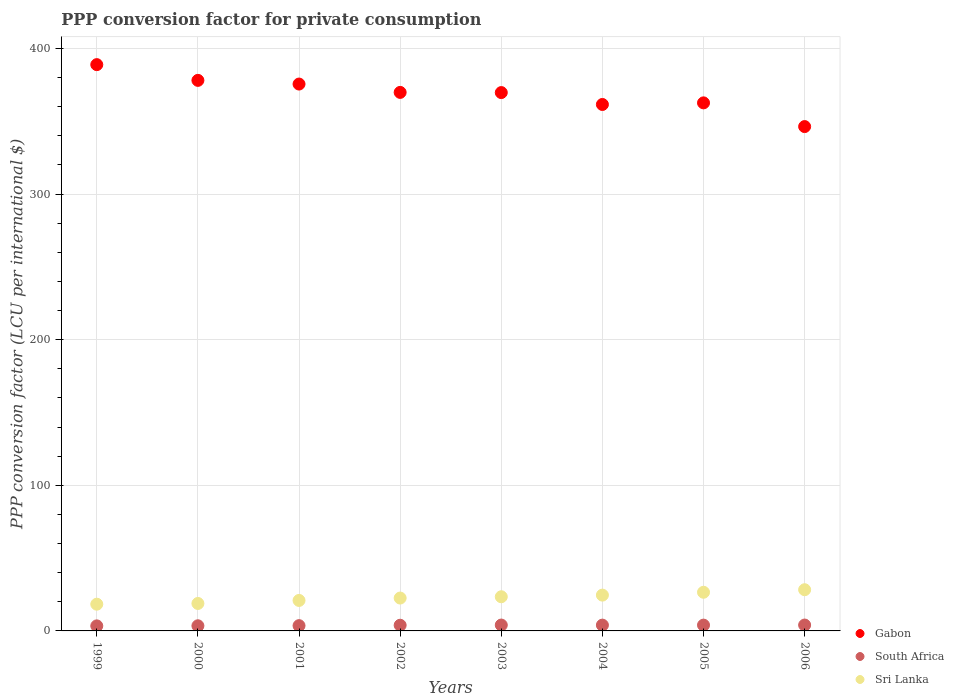How many different coloured dotlines are there?
Your answer should be compact. 3. Is the number of dotlines equal to the number of legend labels?
Give a very brief answer. Yes. What is the PPP conversion factor for private consumption in Sri Lanka in 2006?
Offer a terse response. 28.29. Across all years, what is the maximum PPP conversion factor for private consumption in Sri Lanka?
Your answer should be very brief. 28.29. Across all years, what is the minimum PPP conversion factor for private consumption in South Africa?
Keep it short and to the point. 3.46. What is the total PPP conversion factor for private consumption in Sri Lanka in the graph?
Your response must be concise. 183.59. What is the difference between the PPP conversion factor for private consumption in South Africa in 1999 and that in 2003?
Provide a succinct answer. -0.57. What is the difference between the PPP conversion factor for private consumption in Sri Lanka in 2006 and the PPP conversion factor for private consumption in Gabon in 2000?
Provide a short and direct response. -349.75. What is the average PPP conversion factor for private consumption in Sri Lanka per year?
Ensure brevity in your answer.  22.95. In the year 1999, what is the difference between the PPP conversion factor for private consumption in Sri Lanka and PPP conversion factor for private consumption in South Africa?
Give a very brief answer. 14.89. In how many years, is the PPP conversion factor for private consumption in Sri Lanka greater than 380 LCU?
Your response must be concise. 0. What is the ratio of the PPP conversion factor for private consumption in Sri Lanka in 2004 to that in 2005?
Ensure brevity in your answer.  0.93. Is the PPP conversion factor for private consumption in Gabon in 2001 less than that in 2004?
Your answer should be compact. No. What is the difference between the highest and the second highest PPP conversion factor for private consumption in South Africa?
Ensure brevity in your answer.  0. What is the difference between the highest and the lowest PPP conversion factor for private consumption in Sri Lanka?
Ensure brevity in your answer.  9.94. Is the sum of the PPP conversion factor for private consumption in Gabon in 2002 and 2006 greater than the maximum PPP conversion factor for private consumption in South Africa across all years?
Your answer should be very brief. Yes. Is it the case that in every year, the sum of the PPP conversion factor for private consumption in Sri Lanka and PPP conversion factor for private consumption in Gabon  is greater than the PPP conversion factor for private consumption in South Africa?
Provide a succinct answer. Yes. Is the PPP conversion factor for private consumption in Gabon strictly greater than the PPP conversion factor for private consumption in South Africa over the years?
Your answer should be compact. Yes. Is the PPP conversion factor for private consumption in Sri Lanka strictly less than the PPP conversion factor for private consumption in Gabon over the years?
Your response must be concise. Yes. How many dotlines are there?
Provide a succinct answer. 3. What is the difference between two consecutive major ticks on the Y-axis?
Your answer should be compact. 100. Are the values on the major ticks of Y-axis written in scientific E-notation?
Provide a succinct answer. No. Does the graph contain grids?
Offer a terse response. Yes. How are the legend labels stacked?
Ensure brevity in your answer.  Vertical. What is the title of the graph?
Provide a short and direct response. PPP conversion factor for private consumption. Does "Turks and Caicos Islands" appear as one of the legend labels in the graph?
Your answer should be very brief. No. What is the label or title of the Y-axis?
Offer a very short reply. PPP conversion factor (LCU per international $). What is the PPP conversion factor (LCU per international $) of Gabon in 1999?
Your answer should be compact. 388.84. What is the PPP conversion factor (LCU per international $) of South Africa in 1999?
Ensure brevity in your answer.  3.46. What is the PPP conversion factor (LCU per international $) in Sri Lanka in 1999?
Make the answer very short. 18.36. What is the PPP conversion factor (LCU per international $) of Gabon in 2000?
Make the answer very short. 378.04. What is the PPP conversion factor (LCU per international $) in South Africa in 2000?
Make the answer very short. 3.53. What is the PPP conversion factor (LCU per international $) of Sri Lanka in 2000?
Your answer should be compact. 18.85. What is the PPP conversion factor (LCU per international $) of Gabon in 2001?
Offer a terse response. 375.51. What is the PPP conversion factor (LCU per international $) of South Africa in 2001?
Provide a short and direct response. 3.63. What is the PPP conversion factor (LCU per international $) of Sri Lanka in 2001?
Ensure brevity in your answer.  20.93. What is the PPP conversion factor (LCU per international $) of Gabon in 2002?
Provide a succinct answer. 369.78. What is the PPP conversion factor (LCU per international $) of South Africa in 2002?
Keep it short and to the point. 3.9. What is the PPP conversion factor (LCU per international $) in Sri Lanka in 2002?
Offer a terse response. 22.57. What is the PPP conversion factor (LCU per international $) in Gabon in 2003?
Give a very brief answer. 369.66. What is the PPP conversion factor (LCU per international $) in South Africa in 2003?
Provide a succinct answer. 4.03. What is the PPP conversion factor (LCU per international $) of Sri Lanka in 2003?
Give a very brief answer. 23.46. What is the PPP conversion factor (LCU per international $) of Gabon in 2004?
Ensure brevity in your answer.  361.49. What is the PPP conversion factor (LCU per international $) of South Africa in 2004?
Offer a terse response. 3.98. What is the PPP conversion factor (LCU per international $) of Sri Lanka in 2004?
Ensure brevity in your answer.  24.58. What is the PPP conversion factor (LCU per international $) of Gabon in 2005?
Your response must be concise. 362.59. What is the PPP conversion factor (LCU per international $) in South Africa in 2005?
Give a very brief answer. 3.98. What is the PPP conversion factor (LCU per international $) in Sri Lanka in 2005?
Give a very brief answer. 26.54. What is the PPP conversion factor (LCU per international $) in Gabon in 2006?
Give a very brief answer. 346.31. What is the PPP conversion factor (LCU per international $) of South Africa in 2006?
Ensure brevity in your answer.  4.04. What is the PPP conversion factor (LCU per international $) of Sri Lanka in 2006?
Give a very brief answer. 28.29. Across all years, what is the maximum PPP conversion factor (LCU per international $) of Gabon?
Make the answer very short. 388.84. Across all years, what is the maximum PPP conversion factor (LCU per international $) of South Africa?
Your answer should be compact. 4.04. Across all years, what is the maximum PPP conversion factor (LCU per international $) of Sri Lanka?
Provide a short and direct response. 28.29. Across all years, what is the minimum PPP conversion factor (LCU per international $) in Gabon?
Offer a terse response. 346.31. Across all years, what is the minimum PPP conversion factor (LCU per international $) in South Africa?
Your response must be concise. 3.46. Across all years, what is the minimum PPP conversion factor (LCU per international $) in Sri Lanka?
Your response must be concise. 18.36. What is the total PPP conversion factor (LCU per international $) of Gabon in the graph?
Ensure brevity in your answer.  2952.21. What is the total PPP conversion factor (LCU per international $) of South Africa in the graph?
Offer a terse response. 30.54. What is the total PPP conversion factor (LCU per international $) of Sri Lanka in the graph?
Provide a short and direct response. 183.59. What is the difference between the PPP conversion factor (LCU per international $) in Gabon in 1999 and that in 2000?
Offer a very short reply. 10.8. What is the difference between the PPP conversion factor (LCU per international $) in South Africa in 1999 and that in 2000?
Your answer should be compact. -0.07. What is the difference between the PPP conversion factor (LCU per international $) in Sri Lanka in 1999 and that in 2000?
Provide a short and direct response. -0.5. What is the difference between the PPP conversion factor (LCU per international $) in Gabon in 1999 and that in 2001?
Offer a very short reply. 13.33. What is the difference between the PPP conversion factor (LCU per international $) in South Africa in 1999 and that in 2001?
Make the answer very short. -0.16. What is the difference between the PPP conversion factor (LCU per international $) in Sri Lanka in 1999 and that in 2001?
Your response must be concise. -2.57. What is the difference between the PPP conversion factor (LCU per international $) in Gabon in 1999 and that in 2002?
Make the answer very short. 19.06. What is the difference between the PPP conversion factor (LCU per international $) in South Africa in 1999 and that in 2002?
Your answer should be very brief. -0.43. What is the difference between the PPP conversion factor (LCU per international $) in Sri Lanka in 1999 and that in 2002?
Your response must be concise. -4.22. What is the difference between the PPP conversion factor (LCU per international $) of Gabon in 1999 and that in 2003?
Ensure brevity in your answer.  19.19. What is the difference between the PPP conversion factor (LCU per international $) of South Africa in 1999 and that in 2003?
Your answer should be compact. -0.57. What is the difference between the PPP conversion factor (LCU per international $) in Sri Lanka in 1999 and that in 2003?
Offer a very short reply. -5.11. What is the difference between the PPP conversion factor (LCU per international $) of Gabon in 1999 and that in 2004?
Make the answer very short. 27.36. What is the difference between the PPP conversion factor (LCU per international $) of South Africa in 1999 and that in 2004?
Ensure brevity in your answer.  -0.52. What is the difference between the PPP conversion factor (LCU per international $) of Sri Lanka in 1999 and that in 2004?
Offer a very short reply. -6.23. What is the difference between the PPP conversion factor (LCU per international $) in Gabon in 1999 and that in 2005?
Your answer should be compact. 26.25. What is the difference between the PPP conversion factor (LCU per international $) in South Africa in 1999 and that in 2005?
Ensure brevity in your answer.  -0.52. What is the difference between the PPP conversion factor (LCU per international $) of Sri Lanka in 1999 and that in 2005?
Your answer should be very brief. -8.19. What is the difference between the PPP conversion factor (LCU per international $) in Gabon in 1999 and that in 2006?
Your response must be concise. 42.53. What is the difference between the PPP conversion factor (LCU per international $) in South Africa in 1999 and that in 2006?
Ensure brevity in your answer.  -0.58. What is the difference between the PPP conversion factor (LCU per international $) of Sri Lanka in 1999 and that in 2006?
Provide a succinct answer. -9.94. What is the difference between the PPP conversion factor (LCU per international $) in Gabon in 2000 and that in 2001?
Your answer should be compact. 2.53. What is the difference between the PPP conversion factor (LCU per international $) of South Africa in 2000 and that in 2001?
Offer a very short reply. -0.1. What is the difference between the PPP conversion factor (LCU per international $) in Sri Lanka in 2000 and that in 2001?
Offer a very short reply. -2.08. What is the difference between the PPP conversion factor (LCU per international $) of Gabon in 2000 and that in 2002?
Your answer should be very brief. 8.26. What is the difference between the PPP conversion factor (LCU per international $) of South Africa in 2000 and that in 2002?
Your answer should be compact. -0.37. What is the difference between the PPP conversion factor (LCU per international $) in Sri Lanka in 2000 and that in 2002?
Give a very brief answer. -3.72. What is the difference between the PPP conversion factor (LCU per international $) of Gabon in 2000 and that in 2003?
Ensure brevity in your answer.  8.38. What is the difference between the PPP conversion factor (LCU per international $) in South Africa in 2000 and that in 2003?
Make the answer very short. -0.51. What is the difference between the PPP conversion factor (LCU per international $) of Sri Lanka in 2000 and that in 2003?
Your answer should be very brief. -4.61. What is the difference between the PPP conversion factor (LCU per international $) in Gabon in 2000 and that in 2004?
Provide a succinct answer. 16.55. What is the difference between the PPP conversion factor (LCU per international $) of South Africa in 2000 and that in 2004?
Make the answer very short. -0.46. What is the difference between the PPP conversion factor (LCU per international $) in Sri Lanka in 2000 and that in 2004?
Ensure brevity in your answer.  -5.73. What is the difference between the PPP conversion factor (LCU per international $) of Gabon in 2000 and that in 2005?
Your answer should be very brief. 15.45. What is the difference between the PPP conversion factor (LCU per international $) in South Africa in 2000 and that in 2005?
Give a very brief answer. -0.46. What is the difference between the PPP conversion factor (LCU per international $) of Sri Lanka in 2000 and that in 2005?
Your answer should be very brief. -7.69. What is the difference between the PPP conversion factor (LCU per international $) of Gabon in 2000 and that in 2006?
Your response must be concise. 31.73. What is the difference between the PPP conversion factor (LCU per international $) of South Africa in 2000 and that in 2006?
Your answer should be very brief. -0.51. What is the difference between the PPP conversion factor (LCU per international $) of Sri Lanka in 2000 and that in 2006?
Make the answer very short. -9.44. What is the difference between the PPP conversion factor (LCU per international $) of Gabon in 2001 and that in 2002?
Offer a terse response. 5.73. What is the difference between the PPP conversion factor (LCU per international $) of South Africa in 2001 and that in 2002?
Ensure brevity in your answer.  -0.27. What is the difference between the PPP conversion factor (LCU per international $) in Sri Lanka in 2001 and that in 2002?
Ensure brevity in your answer.  -1.64. What is the difference between the PPP conversion factor (LCU per international $) of Gabon in 2001 and that in 2003?
Provide a succinct answer. 5.85. What is the difference between the PPP conversion factor (LCU per international $) in South Africa in 2001 and that in 2003?
Your answer should be very brief. -0.41. What is the difference between the PPP conversion factor (LCU per international $) in Sri Lanka in 2001 and that in 2003?
Provide a short and direct response. -2.53. What is the difference between the PPP conversion factor (LCU per international $) in Gabon in 2001 and that in 2004?
Your answer should be compact. 14.02. What is the difference between the PPP conversion factor (LCU per international $) of South Africa in 2001 and that in 2004?
Offer a very short reply. -0.36. What is the difference between the PPP conversion factor (LCU per international $) of Sri Lanka in 2001 and that in 2004?
Your response must be concise. -3.65. What is the difference between the PPP conversion factor (LCU per international $) in Gabon in 2001 and that in 2005?
Your answer should be compact. 12.92. What is the difference between the PPP conversion factor (LCU per international $) in South Africa in 2001 and that in 2005?
Give a very brief answer. -0.36. What is the difference between the PPP conversion factor (LCU per international $) in Sri Lanka in 2001 and that in 2005?
Your answer should be very brief. -5.61. What is the difference between the PPP conversion factor (LCU per international $) in Gabon in 2001 and that in 2006?
Ensure brevity in your answer.  29.2. What is the difference between the PPP conversion factor (LCU per international $) of South Africa in 2001 and that in 2006?
Ensure brevity in your answer.  -0.41. What is the difference between the PPP conversion factor (LCU per international $) of Sri Lanka in 2001 and that in 2006?
Your answer should be compact. -7.36. What is the difference between the PPP conversion factor (LCU per international $) in Gabon in 2002 and that in 2003?
Ensure brevity in your answer.  0.13. What is the difference between the PPP conversion factor (LCU per international $) in South Africa in 2002 and that in 2003?
Make the answer very short. -0.14. What is the difference between the PPP conversion factor (LCU per international $) of Sri Lanka in 2002 and that in 2003?
Ensure brevity in your answer.  -0.89. What is the difference between the PPP conversion factor (LCU per international $) of Gabon in 2002 and that in 2004?
Provide a succinct answer. 8.29. What is the difference between the PPP conversion factor (LCU per international $) of South Africa in 2002 and that in 2004?
Provide a succinct answer. -0.09. What is the difference between the PPP conversion factor (LCU per international $) in Sri Lanka in 2002 and that in 2004?
Your response must be concise. -2.01. What is the difference between the PPP conversion factor (LCU per international $) of Gabon in 2002 and that in 2005?
Your response must be concise. 7.19. What is the difference between the PPP conversion factor (LCU per international $) of South Africa in 2002 and that in 2005?
Provide a succinct answer. -0.09. What is the difference between the PPP conversion factor (LCU per international $) of Sri Lanka in 2002 and that in 2005?
Your answer should be very brief. -3.97. What is the difference between the PPP conversion factor (LCU per international $) of Gabon in 2002 and that in 2006?
Your response must be concise. 23.47. What is the difference between the PPP conversion factor (LCU per international $) of South Africa in 2002 and that in 2006?
Your response must be concise. -0.14. What is the difference between the PPP conversion factor (LCU per international $) in Sri Lanka in 2002 and that in 2006?
Keep it short and to the point. -5.72. What is the difference between the PPP conversion factor (LCU per international $) in Gabon in 2003 and that in 2004?
Offer a terse response. 8.17. What is the difference between the PPP conversion factor (LCU per international $) of South Africa in 2003 and that in 2004?
Provide a short and direct response. 0.05. What is the difference between the PPP conversion factor (LCU per international $) in Sri Lanka in 2003 and that in 2004?
Offer a terse response. -1.12. What is the difference between the PPP conversion factor (LCU per international $) in Gabon in 2003 and that in 2005?
Offer a very short reply. 7.07. What is the difference between the PPP conversion factor (LCU per international $) of South Africa in 2003 and that in 2005?
Make the answer very short. 0.05. What is the difference between the PPP conversion factor (LCU per international $) in Sri Lanka in 2003 and that in 2005?
Keep it short and to the point. -3.08. What is the difference between the PPP conversion factor (LCU per international $) of Gabon in 2003 and that in 2006?
Provide a succinct answer. 23.35. What is the difference between the PPP conversion factor (LCU per international $) of South Africa in 2003 and that in 2006?
Offer a terse response. -0. What is the difference between the PPP conversion factor (LCU per international $) of Sri Lanka in 2003 and that in 2006?
Ensure brevity in your answer.  -4.83. What is the difference between the PPP conversion factor (LCU per international $) of Gabon in 2004 and that in 2005?
Make the answer very short. -1.1. What is the difference between the PPP conversion factor (LCU per international $) of South Africa in 2004 and that in 2005?
Provide a succinct answer. -0. What is the difference between the PPP conversion factor (LCU per international $) in Sri Lanka in 2004 and that in 2005?
Provide a succinct answer. -1.96. What is the difference between the PPP conversion factor (LCU per international $) of Gabon in 2004 and that in 2006?
Provide a succinct answer. 15.18. What is the difference between the PPP conversion factor (LCU per international $) in South Africa in 2004 and that in 2006?
Your answer should be very brief. -0.05. What is the difference between the PPP conversion factor (LCU per international $) in Sri Lanka in 2004 and that in 2006?
Your answer should be very brief. -3.71. What is the difference between the PPP conversion factor (LCU per international $) of Gabon in 2005 and that in 2006?
Give a very brief answer. 16.28. What is the difference between the PPP conversion factor (LCU per international $) in South Africa in 2005 and that in 2006?
Give a very brief answer. -0.05. What is the difference between the PPP conversion factor (LCU per international $) in Sri Lanka in 2005 and that in 2006?
Your answer should be compact. -1.75. What is the difference between the PPP conversion factor (LCU per international $) in Gabon in 1999 and the PPP conversion factor (LCU per international $) in South Africa in 2000?
Your answer should be compact. 385.32. What is the difference between the PPP conversion factor (LCU per international $) of Gabon in 1999 and the PPP conversion factor (LCU per international $) of Sri Lanka in 2000?
Give a very brief answer. 369.99. What is the difference between the PPP conversion factor (LCU per international $) of South Africa in 1999 and the PPP conversion factor (LCU per international $) of Sri Lanka in 2000?
Provide a succinct answer. -15.39. What is the difference between the PPP conversion factor (LCU per international $) in Gabon in 1999 and the PPP conversion factor (LCU per international $) in South Africa in 2001?
Provide a succinct answer. 385.22. What is the difference between the PPP conversion factor (LCU per international $) of Gabon in 1999 and the PPP conversion factor (LCU per international $) of Sri Lanka in 2001?
Ensure brevity in your answer.  367.91. What is the difference between the PPP conversion factor (LCU per international $) in South Africa in 1999 and the PPP conversion factor (LCU per international $) in Sri Lanka in 2001?
Your answer should be compact. -17.47. What is the difference between the PPP conversion factor (LCU per international $) in Gabon in 1999 and the PPP conversion factor (LCU per international $) in South Africa in 2002?
Ensure brevity in your answer.  384.95. What is the difference between the PPP conversion factor (LCU per international $) of Gabon in 1999 and the PPP conversion factor (LCU per international $) of Sri Lanka in 2002?
Provide a succinct answer. 366.27. What is the difference between the PPP conversion factor (LCU per international $) of South Africa in 1999 and the PPP conversion factor (LCU per international $) of Sri Lanka in 2002?
Ensure brevity in your answer.  -19.11. What is the difference between the PPP conversion factor (LCU per international $) in Gabon in 1999 and the PPP conversion factor (LCU per international $) in South Africa in 2003?
Keep it short and to the point. 384.81. What is the difference between the PPP conversion factor (LCU per international $) of Gabon in 1999 and the PPP conversion factor (LCU per international $) of Sri Lanka in 2003?
Make the answer very short. 365.38. What is the difference between the PPP conversion factor (LCU per international $) in South Africa in 1999 and the PPP conversion factor (LCU per international $) in Sri Lanka in 2003?
Make the answer very short. -20. What is the difference between the PPP conversion factor (LCU per international $) of Gabon in 1999 and the PPP conversion factor (LCU per international $) of South Africa in 2004?
Provide a short and direct response. 384.86. What is the difference between the PPP conversion factor (LCU per international $) in Gabon in 1999 and the PPP conversion factor (LCU per international $) in Sri Lanka in 2004?
Offer a terse response. 364.26. What is the difference between the PPP conversion factor (LCU per international $) of South Africa in 1999 and the PPP conversion factor (LCU per international $) of Sri Lanka in 2004?
Your response must be concise. -21.12. What is the difference between the PPP conversion factor (LCU per international $) in Gabon in 1999 and the PPP conversion factor (LCU per international $) in South Africa in 2005?
Make the answer very short. 384.86. What is the difference between the PPP conversion factor (LCU per international $) of Gabon in 1999 and the PPP conversion factor (LCU per international $) of Sri Lanka in 2005?
Provide a short and direct response. 362.3. What is the difference between the PPP conversion factor (LCU per international $) in South Africa in 1999 and the PPP conversion factor (LCU per international $) in Sri Lanka in 2005?
Make the answer very short. -23.08. What is the difference between the PPP conversion factor (LCU per international $) in Gabon in 1999 and the PPP conversion factor (LCU per international $) in South Africa in 2006?
Make the answer very short. 384.81. What is the difference between the PPP conversion factor (LCU per international $) of Gabon in 1999 and the PPP conversion factor (LCU per international $) of Sri Lanka in 2006?
Your answer should be compact. 360.55. What is the difference between the PPP conversion factor (LCU per international $) in South Africa in 1999 and the PPP conversion factor (LCU per international $) in Sri Lanka in 2006?
Keep it short and to the point. -24.83. What is the difference between the PPP conversion factor (LCU per international $) of Gabon in 2000 and the PPP conversion factor (LCU per international $) of South Africa in 2001?
Ensure brevity in your answer.  374.41. What is the difference between the PPP conversion factor (LCU per international $) of Gabon in 2000 and the PPP conversion factor (LCU per international $) of Sri Lanka in 2001?
Keep it short and to the point. 357.11. What is the difference between the PPP conversion factor (LCU per international $) in South Africa in 2000 and the PPP conversion factor (LCU per international $) in Sri Lanka in 2001?
Make the answer very short. -17.4. What is the difference between the PPP conversion factor (LCU per international $) in Gabon in 2000 and the PPP conversion factor (LCU per international $) in South Africa in 2002?
Your response must be concise. 374.14. What is the difference between the PPP conversion factor (LCU per international $) in Gabon in 2000 and the PPP conversion factor (LCU per international $) in Sri Lanka in 2002?
Provide a short and direct response. 355.47. What is the difference between the PPP conversion factor (LCU per international $) in South Africa in 2000 and the PPP conversion factor (LCU per international $) in Sri Lanka in 2002?
Ensure brevity in your answer.  -19.04. What is the difference between the PPP conversion factor (LCU per international $) of Gabon in 2000 and the PPP conversion factor (LCU per international $) of South Africa in 2003?
Keep it short and to the point. 374.01. What is the difference between the PPP conversion factor (LCU per international $) of Gabon in 2000 and the PPP conversion factor (LCU per international $) of Sri Lanka in 2003?
Provide a succinct answer. 354.58. What is the difference between the PPP conversion factor (LCU per international $) in South Africa in 2000 and the PPP conversion factor (LCU per international $) in Sri Lanka in 2003?
Keep it short and to the point. -19.94. What is the difference between the PPP conversion factor (LCU per international $) of Gabon in 2000 and the PPP conversion factor (LCU per international $) of South Africa in 2004?
Keep it short and to the point. 374.06. What is the difference between the PPP conversion factor (LCU per international $) of Gabon in 2000 and the PPP conversion factor (LCU per international $) of Sri Lanka in 2004?
Your answer should be very brief. 353.46. What is the difference between the PPP conversion factor (LCU per international $) of South Africa in 2000 and the PPP conversion factor (LCU per international $) of Sri Lanka in 2004?
Your response must be concise. -21.06. What is the difference between the PPP conversion factor (LCU per international $) of Gabon in 2000 and the PPP conversion factor (LCU per international $) of South Africa in 2005?
Provide a short and direct response. 374.06. What is the difference between the PPP conversion factor (LCU per international $) of Gabon in 2000 and the PPP conversion factor (LCU per international $) of Sri Lanka in 2005?
Offer a terse response. 351.5. What is the difference between the PPP conversion factor (LCU per international $) of South Africa in 2000 and the PPP conversion factor (LCU per international $) of Sri Lanka in 2005?
Provide a short and direct response. -23.02. What is the difference between the PPP conversion factor (LCU per international $) in Gabon in 2000 and the PPP conversion factor (LCU per international $) in South Africa in 2006?
Make the answer very short. 374. What is the difference between the PPP conversion factor (LCU per international $) in Gabon in 2000 and the PPP conversion factor (LCU per international $) in Sri Lanka in 2006?
Give a very brief answer. 349.75. What is the difference between the PPP conversion factor (LCU per international $) in South Africa in 2000 and the PPP conversion factor (LCU per international $) in Sri Lanka in 2006?
Offer a very short reply. -24.76. What is the difference between the PPP conversion factor (LCU per international $) of Gabon in 2001 and the PPP conversion factor (LCU per international $) of South Africa in 2002?
Give a very brief answer. 371.61. What is the difference between the PPP conversion factor (LCU per international $) of Gabon in 2001 and the PPP conversion factor (LCU per international $) of Sri Lanka in 2002?
Keep it short and to the point. 352.94. What is the difference between the PPP conversion factor (LCU per international $) of South Africa in 2001 and the PPP conversion factor (LCU per international $) of Sri Lanka in 2002?
Offer a terse response. -18.95. What is the difference between the PPP conversion factor (LCU per international $) in Gabon in 2001 and the PPP conversion factor (LCU per international $) in South Africa in 2003?
Provide a short and direct response. 371.48. What is the difference between the PPP conversion factor (LCU per international $) of Gabon in 2001 and the PPP conversion factor (LCU per international $) of Sri Lanka in 2003?
Make the answer very short. 352.05. What is the difference between the PPP conversion factor (LCU per international $) of South Africa in 2001 and the PPP conversion factor (LCU per international $) of Sri Lanka in 2003?
Offer a terse response. -19.84. What is the difference between the PPP conversion factor (LCU per international $) of Gabon in 2001 and the PPP conversion factor (LCU per international $) of South Africa in 2004?
Provide a succinct answer. 371.53. What is the difference between the PPP conversion factor (LCU per international $) in Gabon in 2001 and the PPP conversion factor (LCU per international $) in Sri Lanka in 2004?
Offer a terse response. 350.93. What is the difference between the PPP conversion factor (LCU per international $) in South Africa in 2001 and the PPP conversion factor (LCU per international $) in Sri Lanka in 2004?
Offer a terse response. -20.96. What is the difference between the PPP conversion factor (LCU per international $) in Gabon in 2001 and the PPP conversion factor (LCU per international $) in South Africa in 2005?
Keep it short and to the point. 371.53. What is the difference between the PPP conversion factor (LCU per international $) of Gabon in 2001 and the PPP conversion factor (LCU per international $) of Sri Lanka in 2005?
Your answer should be compact. 348.96. What is the difference between the PPP conversion factor (LCU per international $) in South Africa in 2001 and the PPP conversion factor (LCU per international $) in Sri Lanka in 2005?
Ensure brevity in your answer.  -22.92. What is the difference between the PPP conversion factor (LCU per international $) of Gabon in 2001 and the PPP conversion factor (LCU per international $) of South Africa in 2006?
Offer a very short reply. 371.47. What is the difference between the PPP conversion factor (LCU per international $) of Gabon in 2001 and the PPP conversion factor (LCU per international $) of Sri Lanka in 2006?
Ensure brevity in your answer.  347.22. What is the difference between the PPP conversion factor (LCU per international $) in South Africa in 2001 and the PPP conversion factor (LCU per international $) in Sri Lanka in 2006?
Give a very brief answer. -24.67. What is the difference between the PPP conversion factor (LCU per international $) in Gabon in 2002 and the PPP conversion factor (LCU per international $) in South Africa in 2003?
Keep it short and to the point. 365.75. What is the difference between the PPP conversion factor (LCU per international $) of Gabon in 2002 and the PPP conversion factor (LCU per international $) of Sri Lanka in 2003?
Ensure brevity in your answer.  346.32. What is the difference between the PPP conversion factor (LCU per international $) in South Africa in 2002 and the PPP conversion factor (LCU per international $) in Sri Lanka in 2003?
Give a very brief answer. -19.57. What is the difference between the PPP conversion factor (LCU per international $) of Gabon in 2002 and the PPP conversion factor (LCU per international $) of South Africa in 2004?
Provide a succinct answer. 365.8. What is the difference between the PPP conversion factor (LCU per international $) of Gabon in 2002 and the PPP conversion factor (LCU per international $) of Sri Lanka in 2004?
Your answer should be very brief. 345.2. What is the difference between the PPP conversion factor (LCU per international $) of South Africa in 2002 and the PPP conversion factor (LCU per international $) of Sri Lanka in 2004?
Your answer should be very brief. -20.69. What is the difference between the PPP conversion factor (LCU per international $) in Gabon in 2002 and the PPP conversion factor (LCU per international $) in South Africa in 2005?
Your answer should be compact. 365.8. What is the difference between the PPP conversion factor (LCU per international $) of Gabon in 2002 and the PPP conversion factor (LCU per international $) of Sri Lanka in 2005?
Provide a short and direct response. 343.24. What is the difference between the PPP conversion factor (LCU per international $) of South Africa in 2002 and the PPP conversion factor (LCU per international $) of Sri Lanka in 2005?
Offer a very short reply. -22.65. What is the difference between the PPP conversion factor (LCU per international $) of Gabon in 2002 and the PPP conversion factor (LCU per international $) of South Africa in 2006?
Give a very brief answer. 365.75. What is the difference between the PPP conversion factor (LCU per international $) in Gabon in 2002 and the PPP conversion factor (LCU per international $) in Sri Lanka in 2006?
Your response must be concise. 341.49. What is the difference between the PPP conversion factor (LCU per international $) in South Africa in 2002 and the PPP conversion factor (LCU per international $) in Sri Lanka in 2006?
Keep it short and to the point. -24.4. What is the difference between the PPP conversion factor (LCU per international $) of Gabon in 2003 and the PPP conversion factor (LCU per international $) of South Africa in 2004?
Keep it short and to the point. 365.67. What is the difference between the PPP conversion factor (LCU per international $) of Gabon in 2003 and the PPP conversion factor (LCU per international $) of Sri Lanka in 2004?
Provide a short and direct response. 345.07. What is the difference between the PPP conversion factor (LCU per international $) of South Africa in 2003 and the PPP conversion factor (LCU per international $) of Sri Lanka in 2004?
Ensure brevity in your answer.  -20.55. What is the difference between the PPP conversion factor (LCU per international $) of Gabon in 2003 and the PPP conversion factor (LCU per international $) of South Africa in 2005?
Your answer should be compact. 365.67. What is the difference between the PPP conversion factor (LCU per international $) of Gabon in 2003 and the PPP conversion factor (LCU per international $) of Sri Lanka in 2005?
Your answer should be compact. 343.11. What is the difference between the PPP conversion factor (LCU per international $) in South Africa in 2003 and the PPP conversion factor (LCU per international $) in Sri Lanka in 2005?
Make the answer very short. -22.51. What is the difference between the PPP conversion factor (LCU per international $) in Gabon in 2003 and the PPP conversion factor (LCU per international $) in South Africa in 2006?
Your answer should be very brief. 365.62. What is the difference between the PPP conversion factor (LCU per international $) of Gabon in 2003 and the PPP conversion factor (LCU per international $) of Sri Lanka in 2006?
Make the answer very short. 341.36. What is the difference between the PPP conversion factor (LCU per international $) of South Africa in 2003 and the PPP conversion factor (LCU per international $) of Sri Lanka in 2006?
Make the answer very short. -24.26. What is the difference between the PPP conversion factor (LCU per international $) of Gabon in 2004 and the PPP conversion factor (LCU per international $) of South Africa in 2005?
Your answer should be compact. 357.51. What is the difference between the PPP conversion factor (LCU per international $) of Gabon in 2004 and the PPP conversion factor (LCU per international $) of Sri Lanka in 2005?
Offer a terse response. 334.94. What is the difference between the PPP conversion factor (LCU per international $) of South Africa in 2004 and the PPP conversion factor (LCU per international $) of Sri Lanka in 2005?
Your answer should be very brief. -22.56. What is the difference between the PPP conversion factor (LCU per international $) of Gabon in 2004 and the PPP conversion factor (LCU per international $) of South Africa in 2006?
Give a very brief answer. 357.45. What is the difference between the PPP conversion factor (LCU per international $) in Gabon in 2004 and the PPP conversion factor (LCU per international $) in Sri Lanka in 2006?
Offer a very short reply. 333.2. What is the difference between the PPP conversion factor (LCU per international $) in South Africa in 2004 and the PPP conversion factor (LCU per international $) in Sri Lanka in 2006?
Make the answer very short. -24.31. What is the difference between the PPP conversion factor (LCU per international $) of Gabon in 2005 and the PPP conversion factor (LCU per international $) of South Africa in 2006?
Provide a succinct answer. 358.55. What is the difference between the PPP conversion factor (LCU per international $) in Gabon in 2005 and the PPP conversion factor (LCU per international $) in Sri Lanka in 2006?
Keep it short and to the point. 334.3. What is the difference between the PPP conversion factor (LCU per international $) of South Africa in 2005 and the PPP conversion factor (LCU per international $) of Sri Lanka in 2006?
Make the answer very short. -24.31. What is the average PPP conversion factor (LCU per international $) in Gabon per year?
Make the answer very short. 369.03. What is the average PPP conversion factor (LCU per international $) of South Africa per year?
Make the answer very short. 3.82. What is the average PPP conversion factor (LCU per international $) in Sri Lanka per year?
Keep it short and to the point. 22.95. In the year 1999, what is the difference between the PPP conversion factor (LCU per international $) in Gabon and PPP conversion factor (LCU per international $) in South Africa?
Make the answer very short. 385.38. In the year 1999, what is the difference between the PPP conversion factor (LCU per international $) of Gabon and PPP conversion factor (LCU per international $) of Sri Lanka?
Provide a short and direct response. 370.49. In the year 1999, what is the difference between the PPP conversion factor (LCU per international $) of South Africa and PPP conversion factor (LCU per international $) of Sri Lanka?
Keep it short and to the point. -14.89. In the year 2000, what is the difference between the PPP conversion factor (LCU per international $) in Gabon and PPP conversion factor (LCU per international $) in South Africa?
Provide a succinct answer. 374.51. In the year 2000, what is the difference between the PPP conversion factor (LCU per international $) of Gabon and PPP conversion factor (LCU per international $) of Sri Lanka?
Provide a succinct answer. 359.19. In the year 2000, what is the difference between the PPP conversion factor (LCU per international $) of South Africa and PPP conversion factor (LCU per international $) of Sri Lanka?
Give a very brief answer. -15.33. In the year 2001, what is the difference between the PPP conversion factor (LCU per international $) of Gabon and PPP conversion factor (LCU per international $) of South Africa?
Provide a succinct answer. 371.88. In the year 2001, what is the difference between the PPP conversion factor (LCU per international $) of Gabon and PPP conversion factor (LCU per international $) of Sri Lanka?
Give a very brief answer. 354.58. In the year 2001, what is the difference between the PPP conversion factor (LCU per international $) in South Africa and PPP conversion factor (LCU per international $) in Sri Lanka?
Your answer should be very brief. -17.3. In the year 2002, what is the difference between the PPP conversion factor (LCU per international $) of Gabon and PPP conversion factor (LCU per international $) of South Africa?
Ensure brevity in your answer.  365.89. In the year 2002, what is the difference between the PPP conversion factor (LCU per international $) of Gabon and PPP conversion factor (LCU per international $) of Sri Lanka?
Give a very brief answer. 347.21. In the year 2002, what is the difference between the PPP conversion factor (LCU per international $) of South Africa and PPP conversion factor (LCU per international $) of Sri Lanka?
Give a very brief answer. -18.68. In the year 2003, what is the difference between the PPP conversion factor (LCU per international $) of Gabon and PPP conversion factor (LCU per international $) of South Africa?
Your answer should be very brief. 365.62. In the year 2003, what is the difference between the PPP conversion factor (LCU per international $) in Gabon and PPP conversion factor (LCU per international $) in Sri Lanka?
Ensure brevity in your answer.  346.19. In the year 2003, what is the difference between the PPP conversion factor (LCU per international $) in South Africa and PPP conversion factor (LCU per international $) in Sri Lanka?
Give a very brief answer. -19.43. In the year 2004, what is the difference between the PPP conversion factor (LCU per international $) of Gabon and PPP conversion factor (LCU per international $) of South Africa?
Your answer should be very brief. 357.51. In the year 2004, what is the difference between the PPP conversion factor (LCU per international $) in Gabon and PPP conversion factor (LCU per international $) in Sri Lanka?
Offer a terse response. 336.9. In the year 2004, what is the difference between the PPP conversion factor (LCU per international $) in South Africa and PPP conversion factor (LCU per international $) in Sri Lanka?
Your response must be concise. -20.6. In the year 2005, what is the difference between the PPP conversion factor (LCU per international $) in Gabon and PPP conversion factor (LCU per international $) in South Africa?
Give a very brief answer. 358.61. In the year 2005, what is the difference between the PPP conversion factor (LCU per international $) in Gabon and PPP conversion factor (LCU per international $) in Sri Lanka?
Ensure brevity in your answer.  336.05. In the year 2005, what is the difference between the PPP conversion factor (LCU per international $) of South Africa and PPP conversion factor (LCU per international $) of Sri Lanka?
Give a very brief answer. -22.56. In the year 2006, what is the difference between the PPP conversion factor (LCU per international $) of Gabon and PPP conversion factor (LCU per international $) of South Africa?
Offer a very short reply. 342.27. In the year 2006, what is the difference between the PPP conversion factor (LCU per international $) of Gabon and PPP conversion factor (LCU per international $) of Sri Lanka?
Provide a succinct answer. 318.02. In the year 2006, what is the difference between the PPP conversion factor (LCU per international $) in South Africa and PPP conversion factor (LCU per international $) in Sri Lanka?
Your response must be concise. -24.25. What is the ratio of the PPP conversion factor (LCU per international $) in Gabon in 1999 to that in 2000?
Give a very brief answer. 1.03. What is the ratio of the PPP conversion factor (LCU per international $) in South Africa in 1999 to that in 2000?
Your answer should be very brief. 0.98. What is the ratio of the PPP conversion factor (LCU per international $) in Sri Lanka in 1999 to that in 2000?
Ensure brevity in your answer.  0.97. What is the ratio of the PPP conversion factor (LCU per international $) in Gabon in 1999 to that in 2001?
Provide a succinct answer. 1.04. What is the ratio of the PPP conversion factor (LCU per international $) in South Africa in 1999 to that in 2001?
Offer a very short reply. 0.95. What is the ratio of the PPP conversion factor (LCU per international $) of Sri Lanka in 1999 to that in 2001?
Provide a short and direct response. 0.88. What is the ratio of the PPP conversion factor (LCU per international $) of Gabon in 1999 to that in 2002?
Offer a terse response. 1.05. What is the ratio of the PPP conversion factor (LCU per international $) of South Africa in 1999 to that in 2002?
Offer a terse response. 0.89. What is the ratio of the PPP conversion factor (LCU per international $) of Sri Lanka in 1999 to that in 2002?
Provide a succinct answer. 0.81. What is the ratio of the PPP conversion factor (LCU per international $) in Gabon in 1999 to that in 2003?
Provide a short and direct response. 1.05. What is the ratio of the PPP conversion factor (LCU per international $) in South Africa in 1999 to that in 2003?
Provide a short and direct response. 0.86. What is the ratio of the PPP conversion factor (LCU per international $) of Sri Lanka in 1999 to that in 2003?
Give a very brief answer. 0.78. What is the ratio of the PPP conversion factor (LCU per international $) in Gabon in 1999 to that in 2004?
Ensure brevity in your answer.  1.08. What is the ratio of the PPP conversion factor (LCU per international $) of South Africa in 1999 to that in 2004?
Make the answer very short. 0.87. What is the ratio of the PPP conversion factor (LCU per international $) in Sri Lanka in 1999 to that in 2004?
Provide a short and direct response. 0.75. What is the ratio of the PPP conversion factor (LCU per international $) in Gabon in 1999 to that in 2005?
Make the answer very short. 1.07. What is the ratio of the PPP conversion factor (LCU per international $) in South Africa in 1999 to that in 2005?
Your answer should be very brief. 0.87. What is the ratio of the PPP conversion factor (LCU per international $) of Sri Lanka in 1999 to that in 2005?
Ensure brevity in your answer.  0.69. What is the ratio of the PPP conversion factor (LCU per international $) of Gabon in 1999 to that in 2006?
Provide a succinct answer. 1.12. What is the ratio of the PPP conversion factor (LCU per international $) of South Africa in 1999 to that in 2006?
Make the answer very short. 0.86. What is the ratio of the PPP conversion factor (LCU per international $) in Sri Lanka in 1999 to that in 2006?
Offer a terse response. 0.65. What is the ratio of the PPP conversion factor (LCU per international $) of South Africa in 2000 to that in 2001?
Your answer should be compact. 0.97. What is the ratio of the PPP conversion factor (LCU per international $) in Sri Lanka in 2000 to that in 2001?
Make the answer very short. 0.9. What is the ratio of the PPP conversion factor (LCU per international $) of Gabon in 2000 to that in 2002?
Your response must be concise. 1.02. What is the ratio of the PPP conversion factor (LCU per international $) in South Africa in 2000 to that in 2002?
Provide a succinct answer. 0.91. What is the ratio of the PPP conversion factor (LCU per international $) of Sri Lanka in 2000 to that in 2002?
Your answer should be very brief. 0.84. What is the ratio of the PPP conversion factor (LCU per international $) in Gabon in 2000 to that in 2003?
Give a very brief answer. 1.02. What is the ratio of the PPP conversion factor (LCU per international $) of South Africa in 2000 to that in 2003?
Your answer should be compact. 0.87. What is the ratio of the PPP conversion factor (LCU per international $) in Sri Lanka in 2000 to that in 2003?
Your response must be concise. 0.8. What is the ratio of the PPP conversion factor (LCU per international $) in Gabon in 2000 to that in 2004?
Provide a succinct answer. 1.05. What is the ratio of the PPP conversion factor (LCU per international $) of South Africa in 2000 to that in 2004?
Your response must be concise. 0.89. What is the ratio of the PPP conversion factor (LCU per international $) in Sri Lanka in 2000 to that in 2004?
Offer a terse response. 0.77. What is the ratio of the PPP conversion factor (LCU per international $) of Gabon in 2000 to that in 2005?
Your response must be concise. 1.04. What is the ratio of the PPP conversion factor (LCU per international $) in South Africa in 2000 to that in 2005?
Provide a succinct answer. 0.89. What is the ratio of the PPP conversion factor (LCU per international $) of Sri Lanka in 2000 to that in 2005?
Give a very brief answer. 0.71. What is the ratio of the PPP conversion factor (LCU per international $) of Gabon in 2000 to that in 2006?
Provide a succinct answer. 1.09. What is the ratio of the PPP conversion factor (LCU per international $) of South Africa in 2000 to that in 2006?
Your response must be concise. 0.87. What is the ratio of the PPP conversion factor (LCU per international $) in Sri Lanka in 2000 to that in 2006?
Ensure brevity in your answer.  0.67. What is the ratio of the PPP conversion factor (LCU per international $) in Gabon in 2001 to that in 2002?
Make the answer very short. 1.02. What is the ratio of the PPP conversion factor (LCU per international $) of South Africa in 2001 to that in 2002?
Offer a terse response. 0.93. What is the ratio of the PPP conversion factor (LCU per international $) in Sri Lanka in 2001 to that in 2002?
Provide a short and direct response. 0.93. What is the ratio of the PPP conversion factor (LCU per international $) in Gabon in 2001 to that in 2003?
Your response must be concise. 1.02. What is the ratio of the PPP conversion factor (LCU per international $) of South Africa in 2001 to that in 2003?
Your answer should be compact. 0.9. What is the ratio of the PPP conversion factor (LCU per international $) of Sri Lanka in 2001 to that in 2003?
Provide a succinct answer. 0.89. What is the ratio of the PPP conversion factor (LCU per international $) in Gabon in 2001 to that in 2004?
Offer a very short reply. 1.04. What is the ratio of the PPP conversion factor (LCU per international $) in South Africa in 2001 to that in 2004?
Make the answer very short. 0.91. What is the ratio of the PPP conversion factor (LCU per international $) of Sri Lanka in 2001 to that in 2004?
Keep it short and to the point. 0.85. What is the ratio of the PPP conversion factor (LCU per international $) in Gabon in 2001 to that in 2005?
Your response must be concise. 1.04. What is the ratio of the PPP conversion factor (LCU per international $) in South Africa in 2001 to that in 2005?
Make the answer very short. 0.91. What is the ratio of the PPP conversion factor (LCU per international $) in Sri Lanka in 2001 to that in 2005?
Offer a terse response. 0.79. What is the ratio of the PPP conversion factor (LCU per international $) of Gabon in 2001 to that in 2006?
Offer a very short reply. 1.08. What is the ratio of the PPP conversion factor (LCU per international $) of South Africa in 2001 to that in 2006?
Provide a succinct answer. 0.9. What is the ratio of the PPP conversion factor (LCU per international $) in Sri Lanka in 2001 to that in 2006?
Offer a very short reply. 0.74. What is the ratio of the PPP conversion factor (LCU per international $) in South Africa in 2002 to that in 2003?
Your response must be concise. 0.97. What is the ratio of the PPP conversion factor (LCU per international $) of Sri Lanka in 2002 to that in 2003?
Provide a succinct answer. 0.96. What is the ratio of the PPP conversion factor (LCU per international $) of Gabon in 2002 to that in 2004?
Ensure brevity in your answer.  1.02. What is the ratio of the PPP conversion factor (LCU per international $) in South Africa in 2002 to that in 2004?
Your answer should be compact. 0.98. What is the ratio of the PPP conversion factor (LCU per international $) of Sri Lanka in 2002 to that in 2004?
Provide a succinct answer. 0.92. What is the ratio of the PPP conversion factor (LCU per international $) in Gabon in 2002 to that in 2005?
Provide a succinct answer. 1.02. What is the ratio of the PPP conversion factor (LCU per international $) in South Africa in 2002 to that in 2005?
Your answer should be compact. 0.98. What is the ratio of the PPP conversion factor (LCU per international $) of Sri Lanka in 2002 to that in 2005?
Provide a short and direct response. 0.85. What is the ratio of the PPP conversion factor (LCU per international $) of Gabon in 2002 to that in 2006?
Offer a terse response. 1.07. What is the ratio of the PPP conversion factor (LCU per international $) of South Africa in 2002 to that in 2006?
Offer a terse response. 0.97. What is the ratio of the PPP conversion factor (LCU per international $) in Sri Lanka in 2002 to that in 2006?
Your response must be concise. 0.8. What is the ratio of the PPP conversion factor (LCU per international $) in Gabon in 2003 to that in 2004?
Offer a very short reply. 1.02. What is the ratio of the PPP conversion factor (LCU per international $) in South Africa in 2003 to that in 2004?
Provide a succinct answer. 1.01. What is the ratio of the PPP conversion factor (LCU per international $) of Sri Lanka in 2003 to that in 2004?
Offer a very short reply. 0.95. What is the ratio of the PPP conversion factor (LCU per international $) of Gabon in 2003 to that in 2005?
Ensure brevity in your answer.  1.02. What is the ratio of the PPP conversion factor (LCU per international $) in South Africa in 2003 to that in 2005?
Your response must be concise. 1.01. What is the ratio of the PPP conversion factor (LCU per international $) of Sri Lanka in 2003 to that in 2005?
Ensure brevity in your answer.  0.88. What is the ratio of the PPP conversion factor (LCU per international $) of Gabon in 2003 to that in 2006?
Your answer should be compact. 1.07. What is the ratio of the PPP conversion factor (LCU per international $) of Sri Lanka in 2003 to that in 2006?
Your response must be concise. 0.83. What is the ratio of the PPP conversion factor (LCU per international $) in Gabon in 2004 to that in 2005?
Give a very brief answer. 1. What is the ratio of the PPP conversion factor (LCU per international $) of South Africa in 2004 to that in 2005?
Keep it short and to the point. 1. What is the ratio of the PPP conversion factor (LCU per international $) of Sri Lanka in 2004 to that in 2005?
Your response must be concise. 0.93. What is the ratio of the PPP conversion factor (LCU per international $) in Gabon in 2004 to that in 2006?
Give a very brief answer. 1.04. What is the ratio of the PPP conversion factor (LCU per international $) in South Africa in 2004 to that in 2006?
Your answer should be compact. 0.99. What is the ratio of the PPP conversion factor (LCU per international $) of Sri Lanka in 2004 to that in 2006?
Keep it short and to the point. 0.87. What is the ratio of the PPP conversion factor (LCU per international $) of Gabon in 2005 to that in 2006?
Make the answer very short. 1.05. What is the ratio of the PPP conversion factor (LCU per international $) in South Africa in 2005 to that in 2006?
Your answer should be compact. 0.99. What is the ratio of the PPP conversion factor (LCU per international $) of Sri Lanka in 2005 to that in 2006?
Ensure brevity in your answer.  0.94. What is the difference between the highest and the second highest PPP conversion factor (LCU per international $) of Gabon?
Your answer should be very brief. 10.8. What is the difference between the highest and the second highest PPP conversion factor (LCU per international $) in South Africa?
Your answer should be compact. 0. What is the difference between the highest and the second highest PPP conversion factor (LCU per international $) in Sri Lanka?
Your response must be concise. 1.75. What is the difference between the highest and the lowest PPP conversion factor (LCU per international $) of Gabon?
Offer a terse response. 42.53. What is the difference between the highest and the lowest PPP conversion factor (LCU per international $) in South Africa?
Your answer should be very brief. 0.58. What is the difference between the highest and the lowest PPP conversion factor (LCU per international $) of Sri Lanka?
Provide a short and direct response. 9.94. 